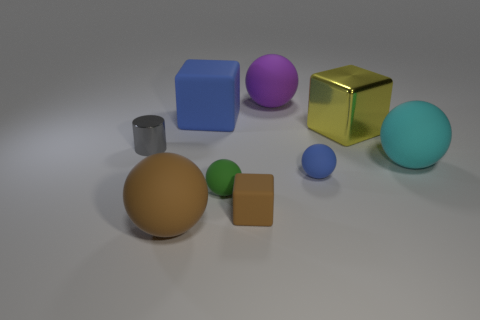What number of spheres are small rubber objects or small gray shiny objects?
Offer a terse response. 2. The matte thing in front of the brown matte cube is what color?
Keep it short and to the point. Brown. How many matte things are balls or purple things?
Your answer should be compact. 5. The thing that is left of the rubber object that is in front of the tiny brown matte object is made of what material?
Offer a terse response. Metal. There is a small thing that is the same color as the big matte block; what is it made of?
Ensure brevity in your answer.  Rubber. The tiny rubber cube has what color?
Provide a succinct answer. Brown. Are there any cyan things in front of the small blue thing that is in front of the big blue rubber block?
Offer a terse response. No. What material is the tiny gray thing?
Give a very brief answer. Metal. Do the blue object that is in front of the large metallic thing and the tiny object that is left of the small green ball have the same material?
Offer a terse response. No. Is there any other thing that is the same color as the tiny cylinder?
Keep it short and to the point. No. 